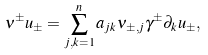<formula> <loc_0><loc_0><loc_500><loc_500>\nu ^ { \pm } u _ { \pm } = \sum _ { j , k = 1 } ^ { n } a _ { j k } \nu _ { \pm , j } \gamma ^ { \pm } \partial _ { k } u _ { \pm } ,</formula> 